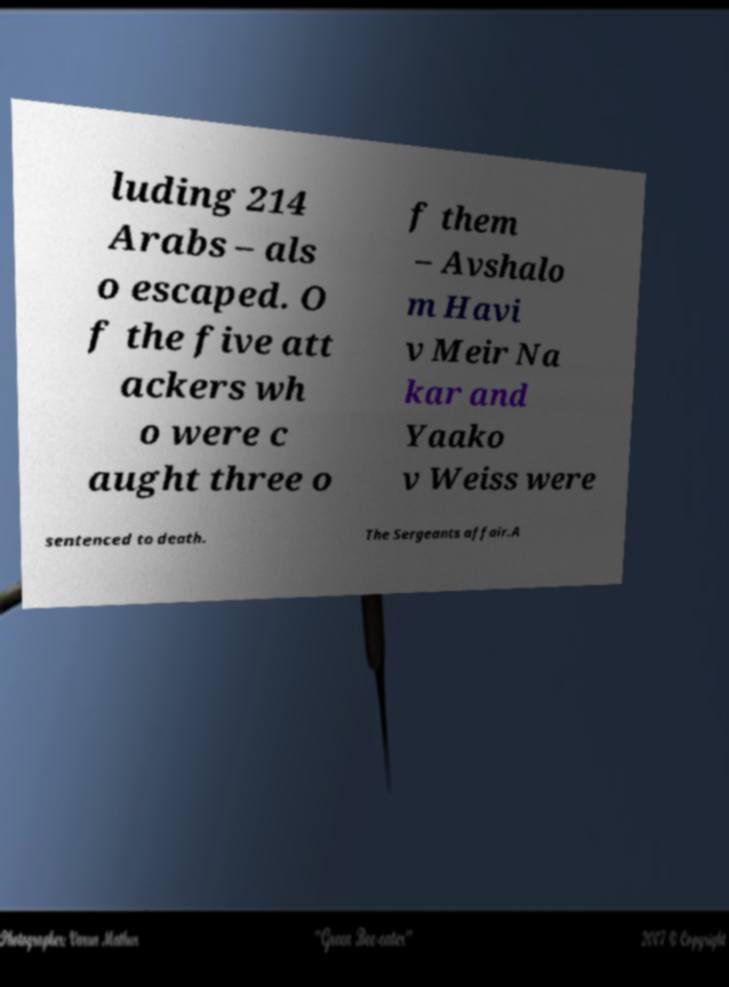For documentation purposes, I need the text within this image transcribed. Could you provide that? luding 214 Arabs – als o escaped. O f the five att ackers wh o were c aught three o f them – Avshalo m Havi v Meir Na kar and Yaako v Weiss were sentenced to death. The Sergeants affair.A 